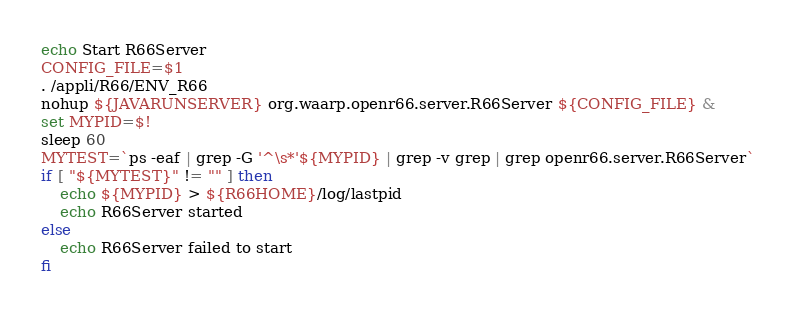Convert code to text. <code><loc_0><loc_0><loc_500><loc_500><_Bash_>echo Start R66Server
CONFIG_FILE=$1
. /appli/R66/ENV_R66
nohup ${JAVARUNSERVER} org.waarp.openr66.server.R66Server ${CONFIG_FILE} &
set MYPID=$!
sleep 60
MYTEST=`ps -eaf | grep -G '^\s*'${MYPID} | grep -v grep | grep openr66.server.R66Server`
if [ "${MYTEST}" != "" ] then 
	echo ${MYPID} > ${R66HOME}/log/lastpid
	echo R66Server started
else
	echo R66Server failed to start
fi
</code> 